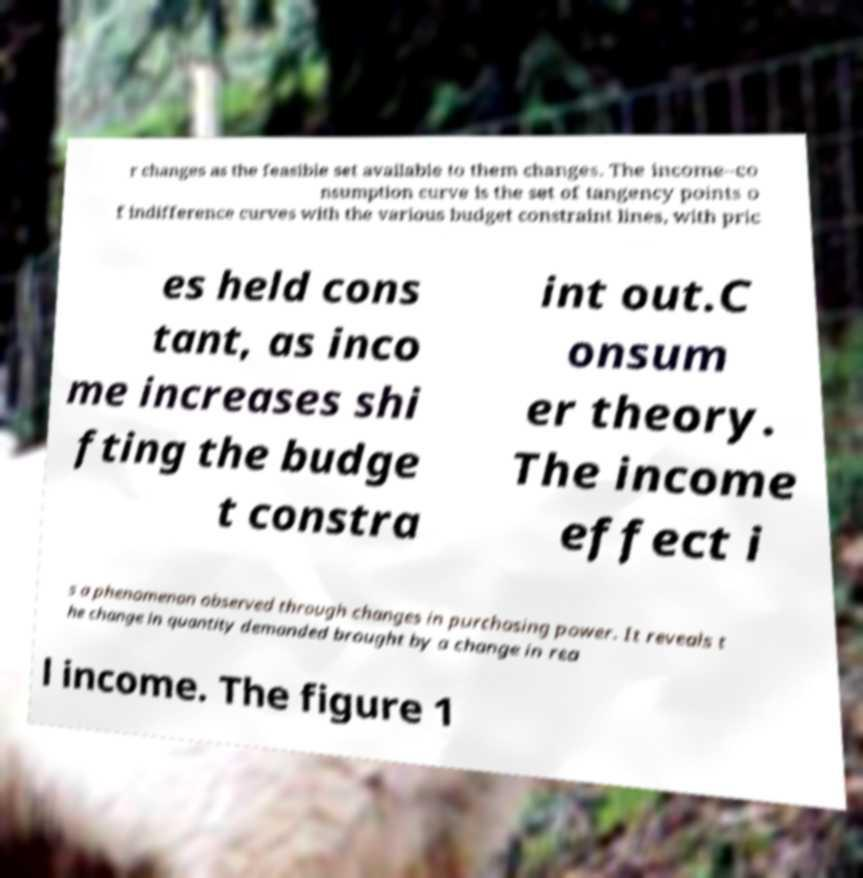Can you accurately transcribe the text from the provided image for me? r changes as the feasible set available to them changes. The income–co nsumption curve is the set of tangency points o f indifference curves with the various budget constraint lines, with pric es held cons tant, as inco me increases shi fting the budge t constra int out.C onsum er theory. The income effect i s a phenomenon observed through changes in purchasing power. It reveals t he change in quantity demanded brought by a change in rea l income. The figure 1 